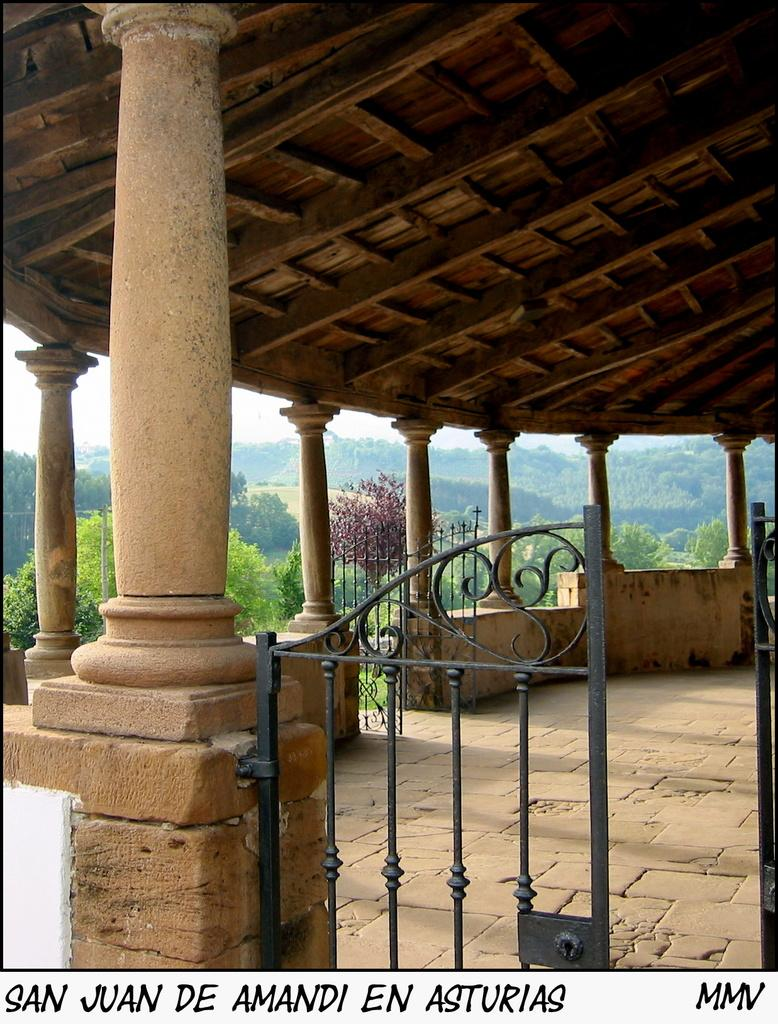What type of gate is shown in the image? There is an iron gate in the image. What is the color of the iron gate? The iron gate is black in color. What can be seen in the background of the image? There are trees visible in the background of the image. What type of scene is depicted in the image? The image depicts a construction scene. What type of nation is represented by the baseball team in the image? There is no baseball team or nation present in the image; it features an iron gate and a construction scene. 